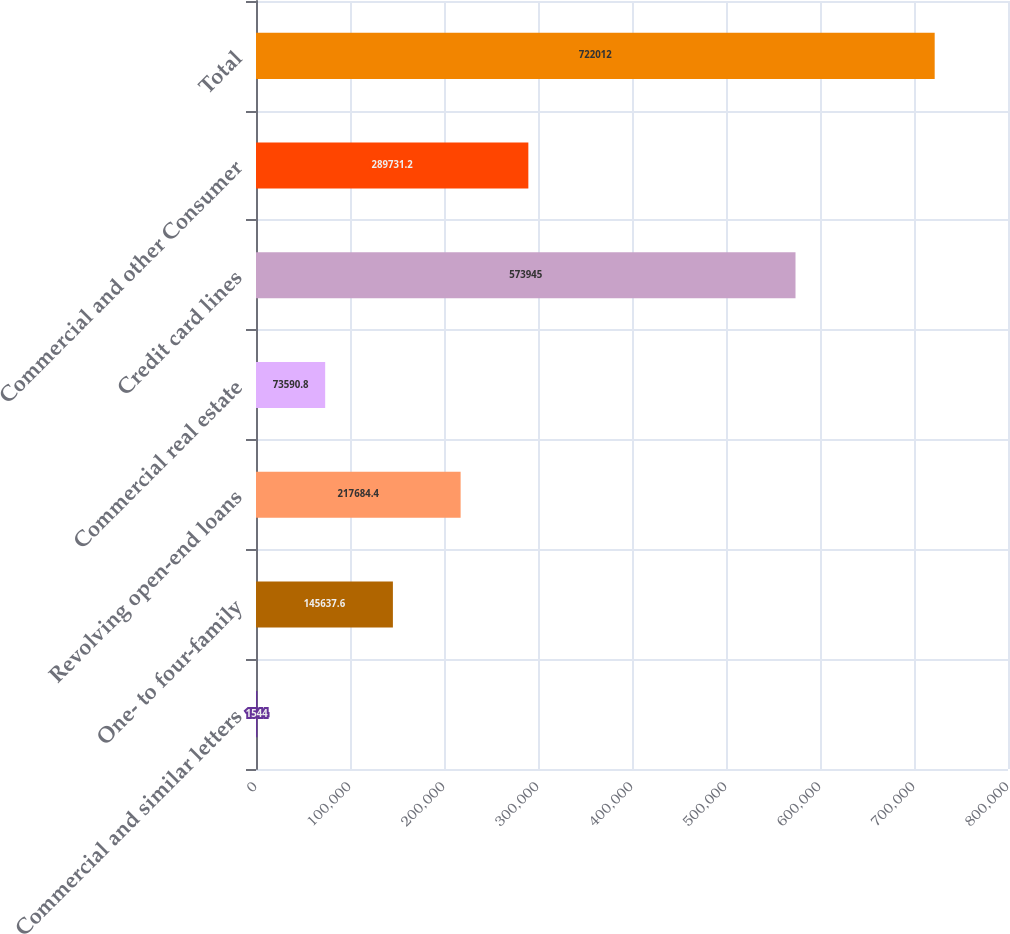<chart> <loc_0><loc_0><loc_500><loc_500><bar_chart><fcel>Commercial and similar letters<fcel>One- to four-family<fcel>Revolving open-end loans<fcel>Commercial real estate<fcel>Credit card lines<fcel>Commercial and other Consumer<fcel>Total<nl><fcel>1544<fcel>145638<fcel>217684<fcel>73590.8<fcel>573945<fcel>289731<fcel>722012<nl></chart> 